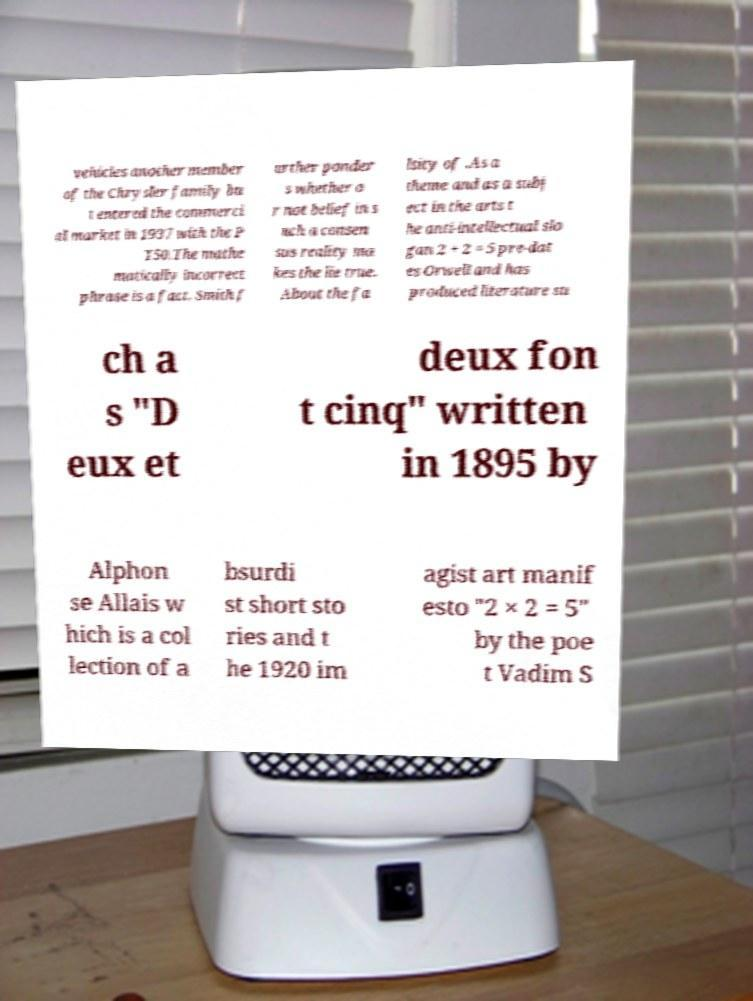For documentation purposes, I need the text within this image transcribed. Could you provide that? vehicles another member of the Chrysler family bu t entered the commerci al market in 1937 with the P T50.The mathe matically incorrect phrase is a fact. Smith f urther ponder s whether o r not belief in s uch a consen sus reality ma kes the lie true. About the fa lsity of .As a theme and as a subj ect in the arts t he anti-intellectual slo gan 2 + 2 = 5 pre-dat es Orwell and has produced literature su ch a s "D eux et deux fon t cinq" written in 1895 by Alphon se Allais w hich is a col lection of a bsurdi st short sto ries and t he 1920 im agist art manif esto "2 × 2 = 5" by the poe t Vadim S 